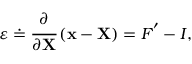<formula> <loc_0><loc_0><loc_500><loc_500>{ \varepsilon } \doteq { \cfrac { \partial } { \partial X } } \left ( x - X \right ) = { F } ^ { \prime } - { I } ,</formula> 